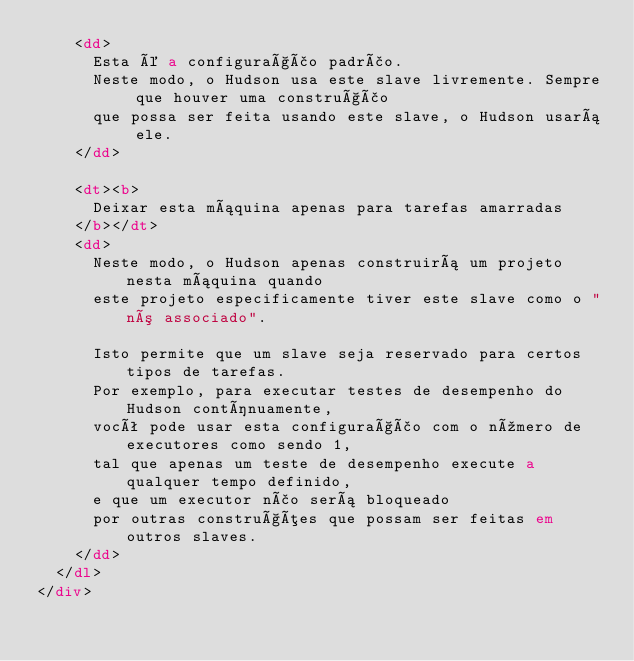Convert code to text. <code><loc_0><loc_0><loc_500><loc_500><_HTML_>    <dd>
      Esta é a configuração padrão.
      Neste modo, o Hudson usa este slave livremente. Sempre que houver uma construção
      que possa ser feita usando este slave, o Hudson usará ele.
    </dd>

    <dt><b>
      Deixar esta máquina apenas para tarefas amarradas
    </b></dt>
    <dd>
      Neste modo, o Hudson apenas construirá um projeto nesta máquina quando
      este projeto especificamente tiver este slave como o "nó associado".

      Isto permite que um slave seja reservado para certos tipos de tarefas.
      Por exemplo, para executar testes de desempenho do Hudson contínuamente,
      você pode usar esta configuração com o número de executores como sendo 1, 
      tal que apenas um teste de desempenho execute a qualquer tempo definido, 
      e que um executor não será bloqueado
      por outras construções que possam ser feitas em outros slaves.
    </dd>
  </dl>
</div></code> 